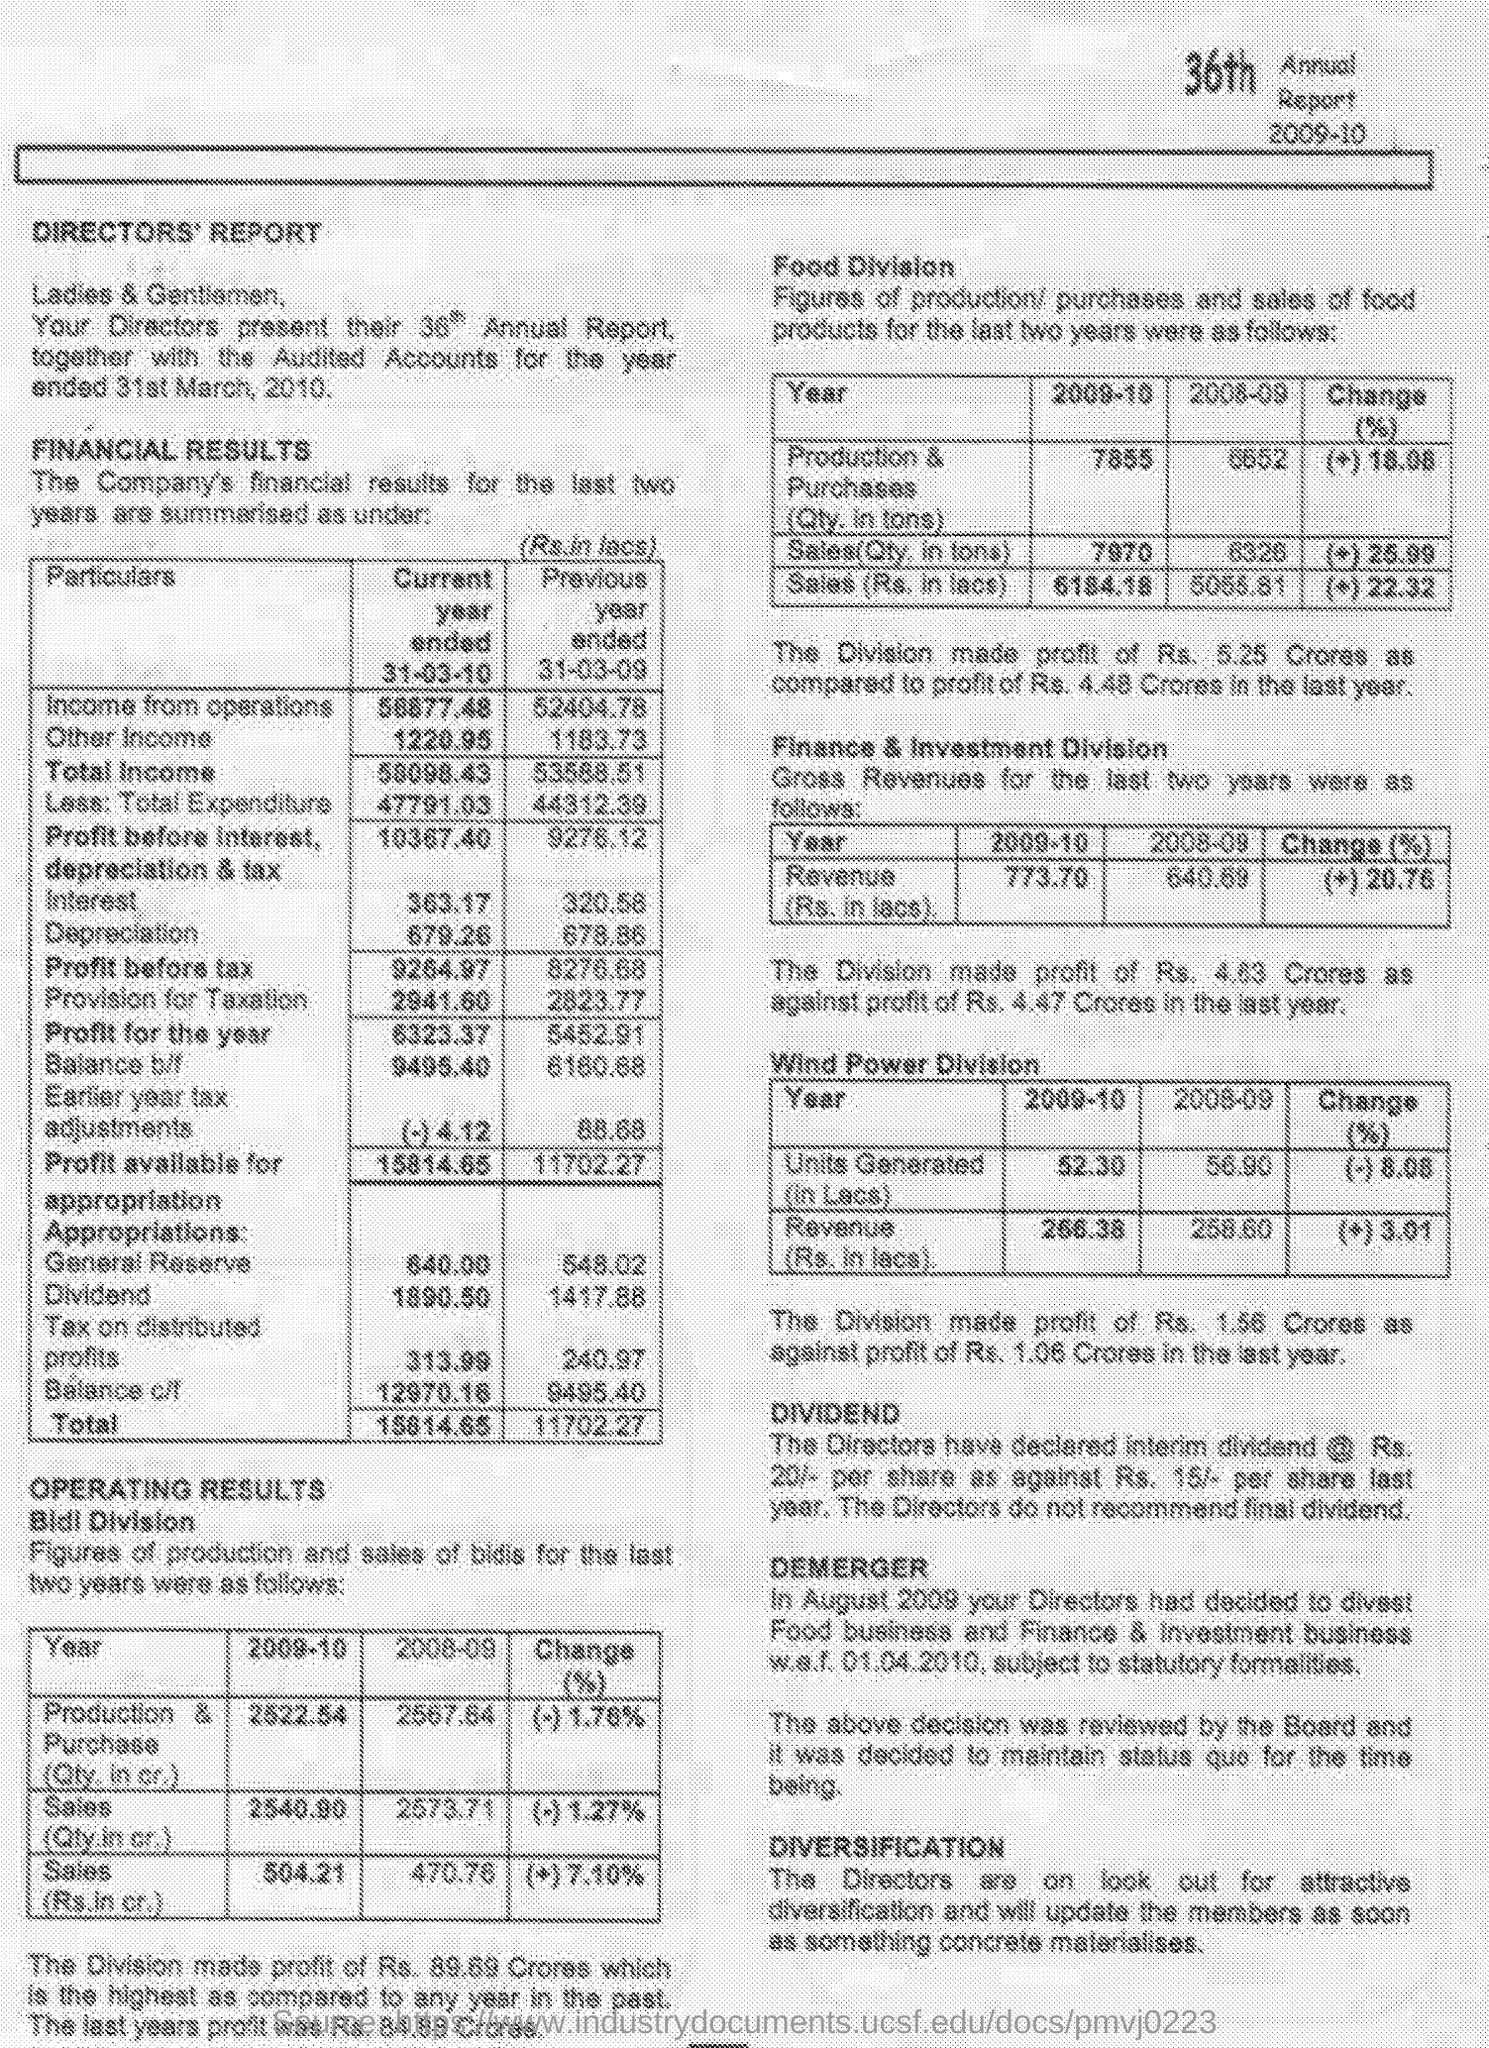Which year is mentioned under "36th Annual Report" given at the right top corner of page?
Keep it short and to the point. 2009-10. What is "Income from operations" for "Current year ended 31-03-10" mentioned under conpany's FINANCIAL RESULTS ?
Your answer should be very brief. 58877.48. What is "Income from operations" for "Previous year ended 31-03-09" mentioned under conpany's FINANCIAL RESULTS ?
Offer a terse response. 52404.78. Provide the "Sales(Rs. in cr.)" in 2009-10 for "Bldl Division"?
Your answer should be very brief. 504.21. Provide the "Sales(Rs. in cr.)" in 2008-9 for "Bldl Division"?
Keep it short and to the point. 470.76. Provide the "Sales(Rs. in lacs)" in 2009-10 for "Food Division"?
Your answer should be very brief. 6184.18. Provide the "Sales(Rs. in lacs)" in 2008-09 for "Food Division"?
Provide a succinct answer. 5055.81. What is the profit of "Finance & Investment Division" in the current year?
Make the answer very short. Rs 4.63 Crores. What is the "Revenue(Rs. in lacs)" in 2009-10 for "Wind Power Division"?
Provide a short and direct response. 266.38. What is the "Revenue(Rs. in lacs)" in 2008-9 for "Wind Power Division"?
Your answer should be compact. 258.60. 